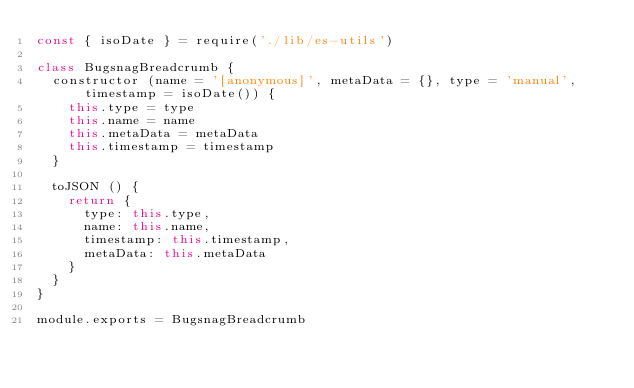<code> <loc_0><loc_0><loc_500><loc_500><_JavaScript_>const { isoDate } = require('./lib/es-utils')

class BugsnagBreadcrumb {
  constructor (name = '[anonymous]', metaData = {}, type = 'manual', timestamp = isoDate()) {
    this.type = type
    this.name = name
    this.metaData = metaData
    this.timestamp = timestamp
  }

  toJSON () {
    return {
      type: this.type,
      name: this.name,
      timestamp: this.timestamp,
      metaData: this.metaData
    }
  }
}

module.exports = BugsnagBreadcrumb
</code> 